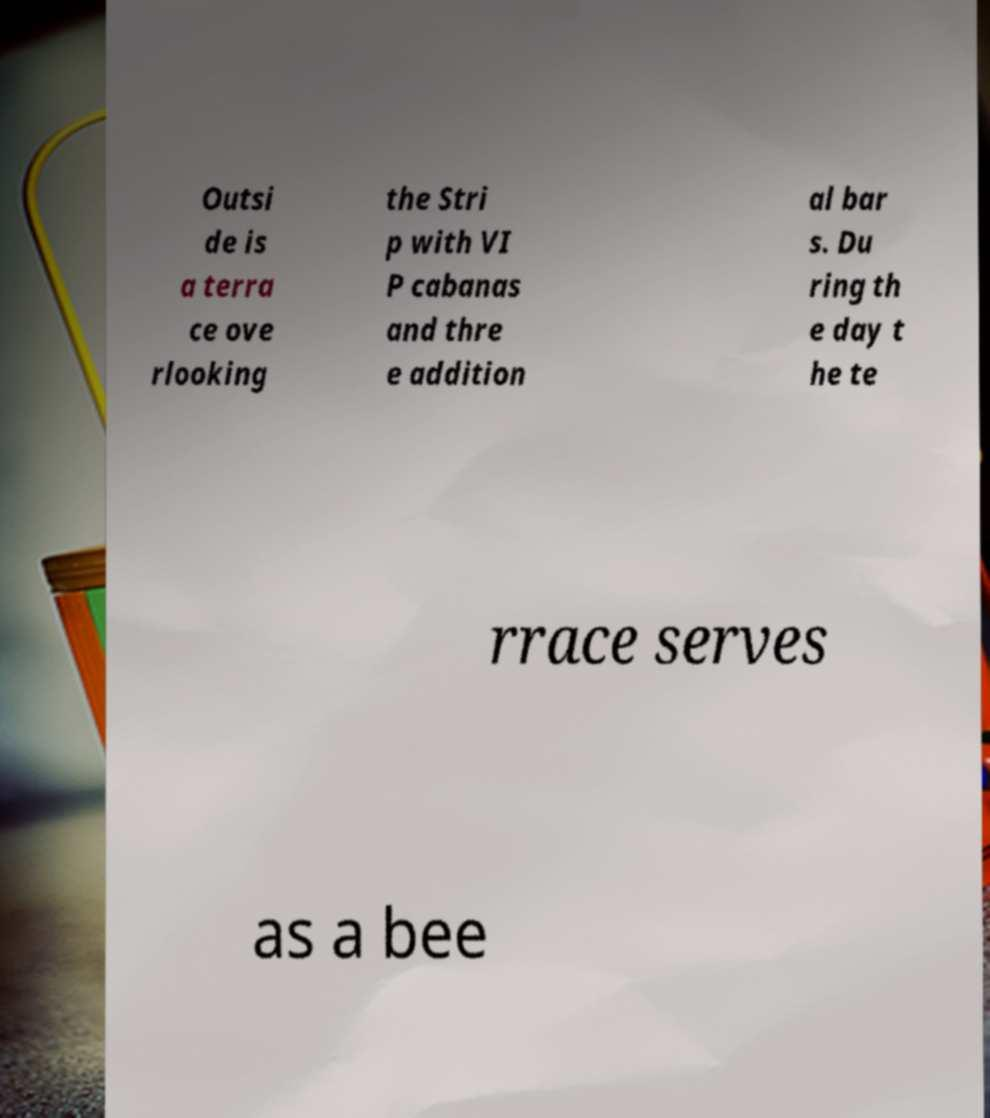For documentation purposes, I need the text within this image transcribed. Could you provide that? Outsi de is a terra ce ove rlooking the Stri p with VI P cabanas and thre e addition al bar s. Du ring th e day t he te rrace serves as a bee 